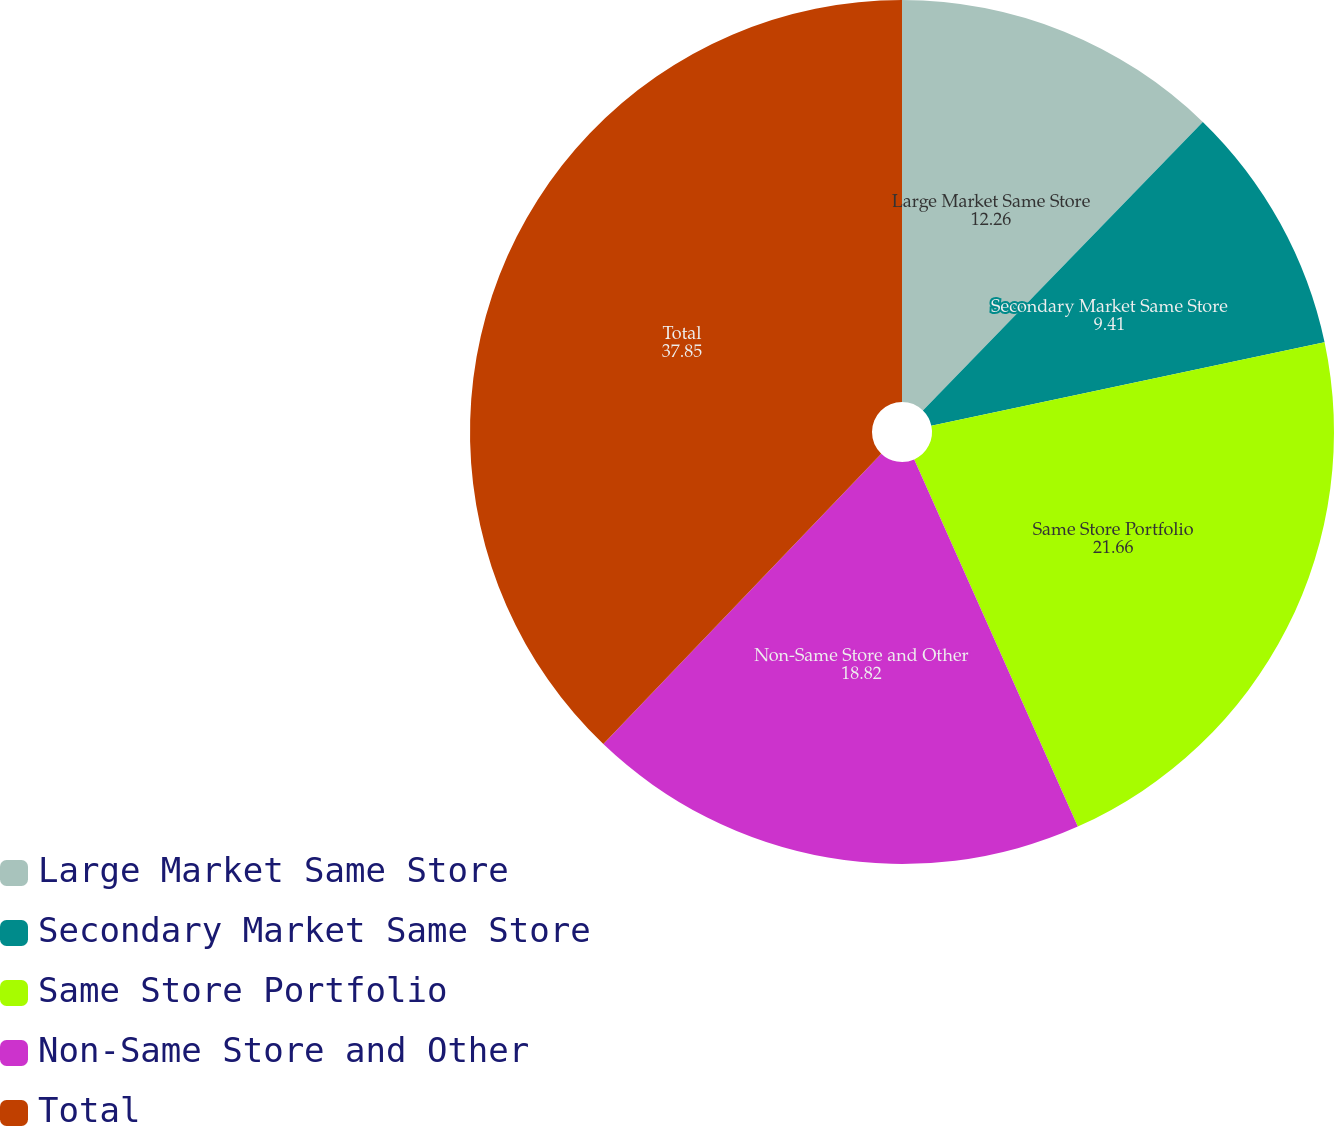Convert chart. <chart><loc_0><loc_0><loc_500><loc_500><pie_chart><fcel>Large Market Same Store<fcel>Secondary Market Same Store<fcel>Same Store Portfolio<fcel>Non-Same Store and Other<fcel>Total<nl><fcel>12.26%<fcel>9.41%<fcel>21.66%<fcel>18.82%<fcel>37.85%<nl></chart> 